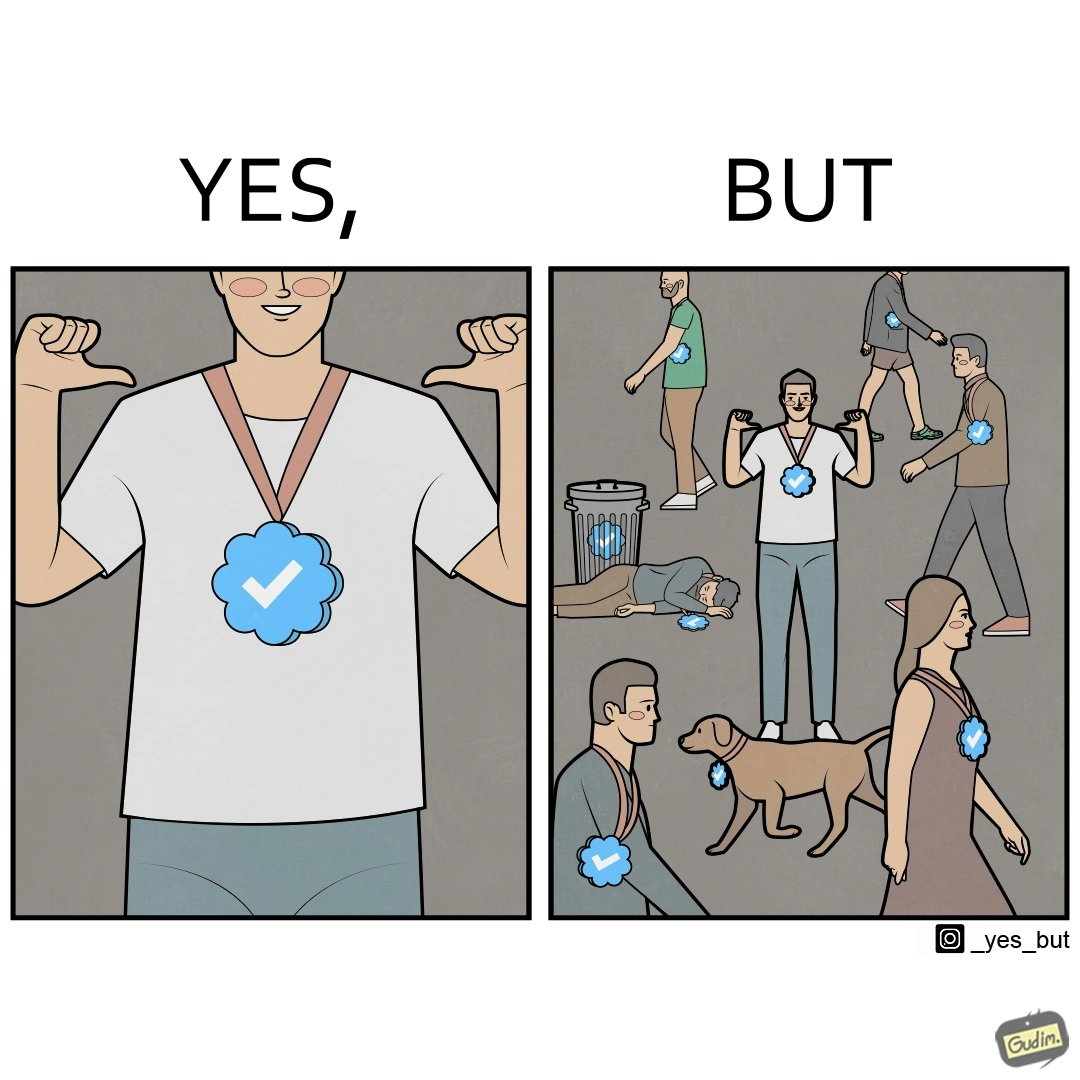Would you classify this image as satirical? Yes, this image is satirical. 